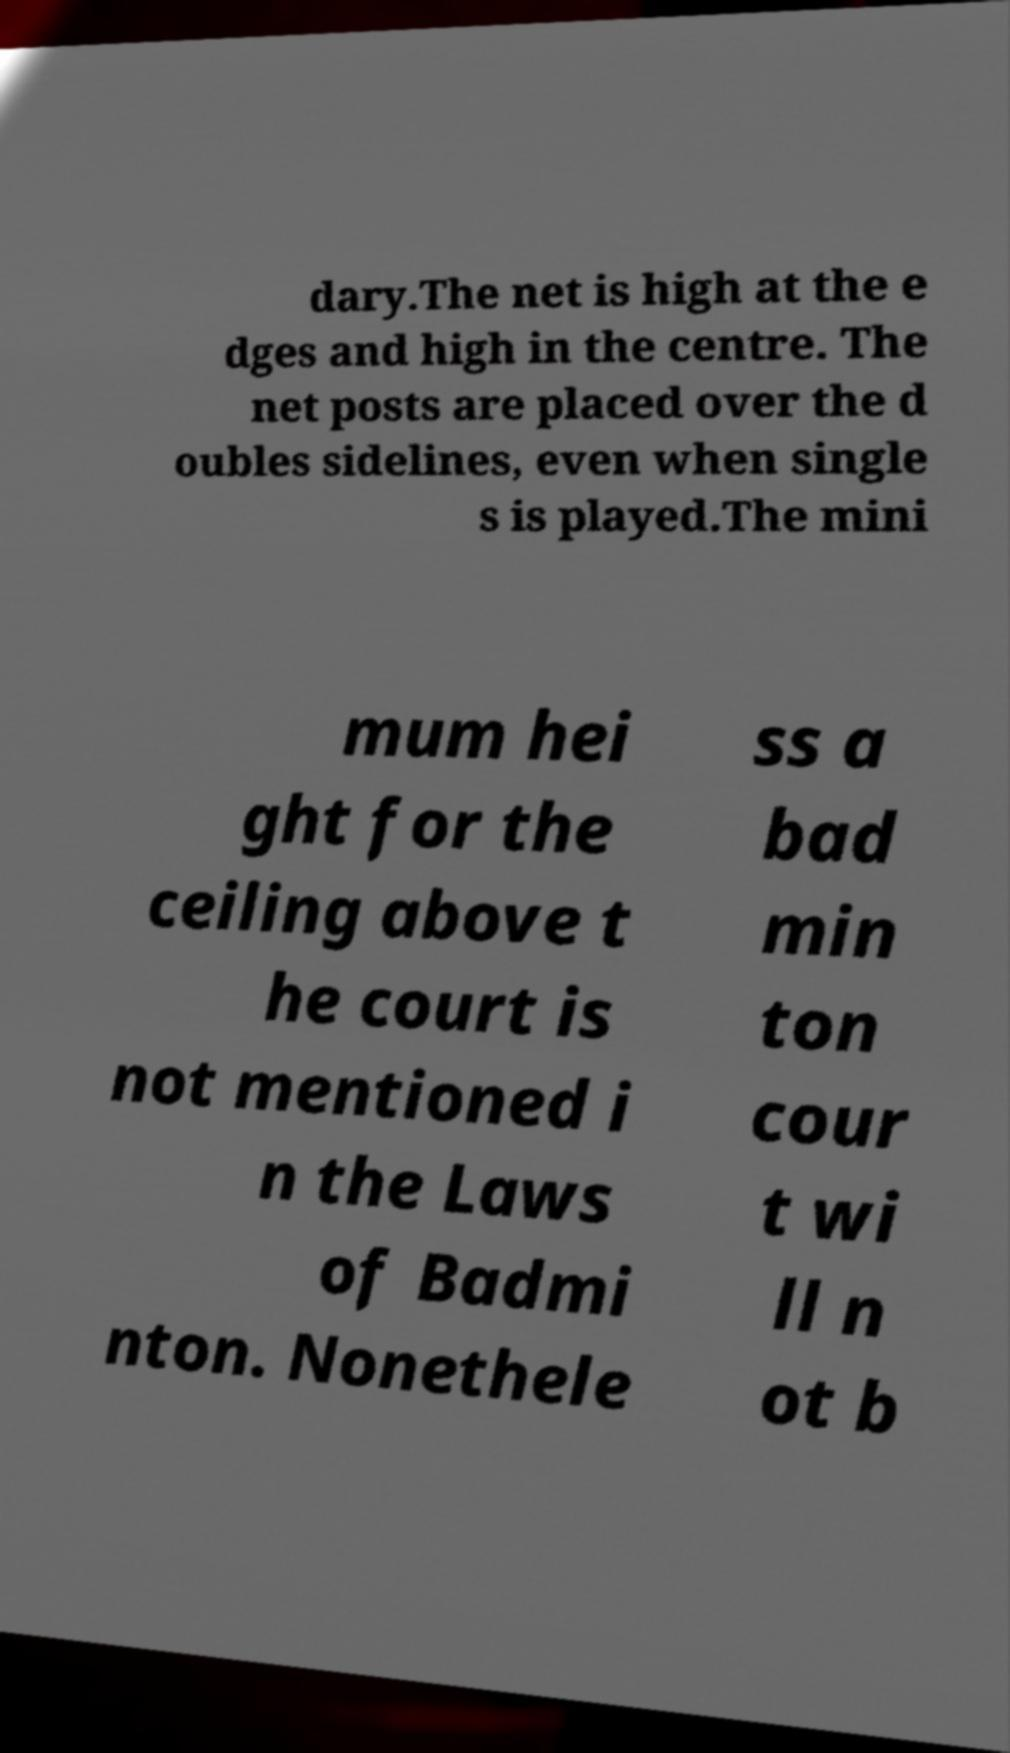What messages or text are displayed in this image? I need them in a readable, typed format. dary.The net is high at the e dges and high in the centre. The net posts are placed over the d oubles sidelines, even when single s is played.The mini mum hei ght for the ceiling above t he court is not mentioned i n the Laws of Badmi nton. Nonethele ss a bad min ton cour t wi ll n ot b 